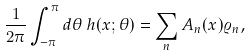Convert formula to latex. <formula><loc_0><loc_0><loc_500><loc_500>\frac { 1 } { 2 \pi } \int _ { - \pi } ^ { \pi } d \theta \, h ( x ; \theta ) = \sum _ { n } A _ { n } ( x ) \varrho _ { n } ,</formula> 